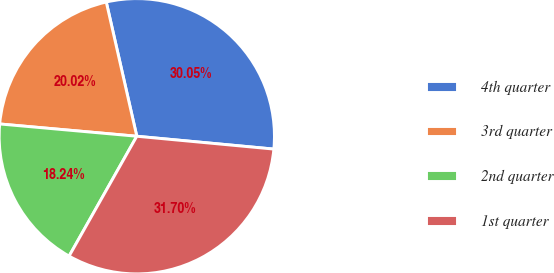Convert chart. <chart><loc_0><loc_0><loc_500><loc_500><pie_chart><fcel>4th quarter<fcel>3rd quarter<fcel>2nd quarter<fcel>1st quarter<nl><fcel>30.05%<fcel>20.02%<fcel>18.24%<fcel>31.7%<nl></chart> 